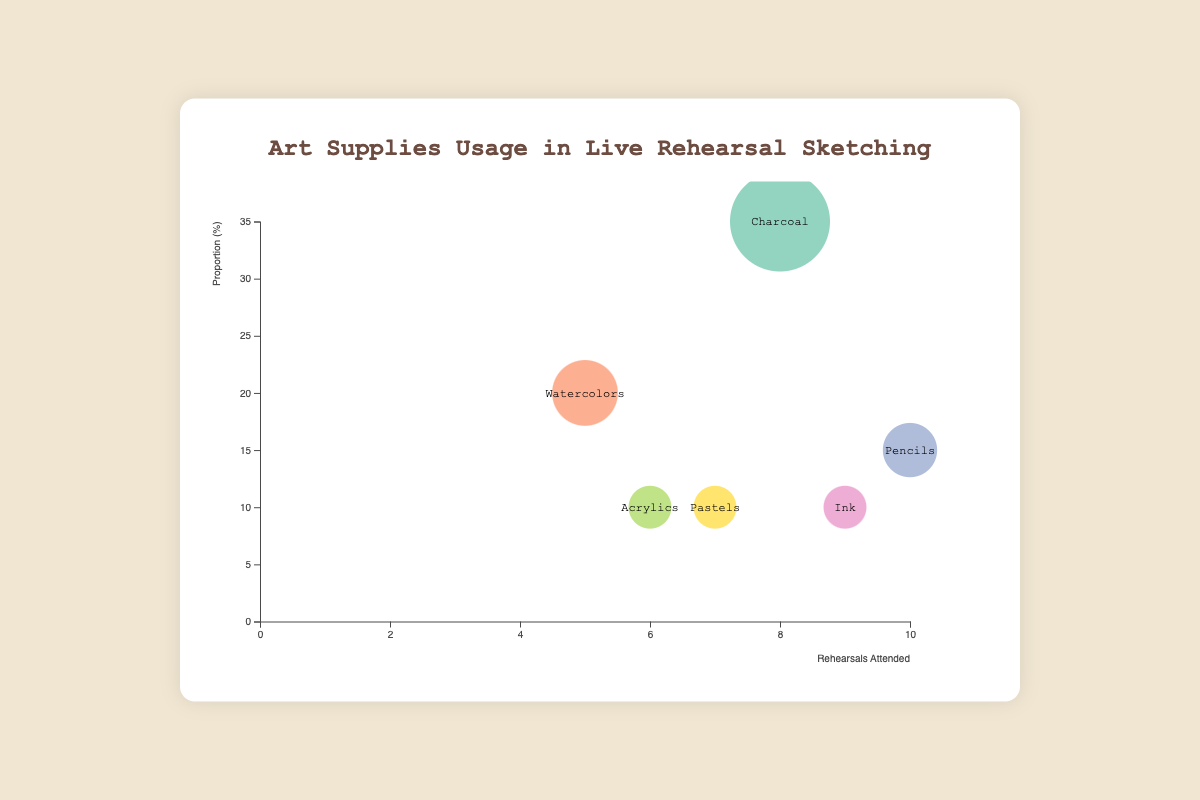What is the title of the figure? The title is usually displayed at the top of the chart.
Answer: Art Supplies Usage in Live Rehearsal Sketching How many different types of art supplies are represented in the figure? Counting the unique types of art supplies listed in the data points reveals the number of different types.
Answer: 6 Which artist uses Charcoal and what is their proportion of usage? By locating the bubble labeled "Charcoal" and checking the tooltip, you find the related artist and their usage proportion.
Answer: Winslow Homer, 35% Between Pastels and Ink, which type of art supply had more rehearsals attended? Compare the "Rehearsals Attended" values for "Pastels" and "Ink" from the bubbles or tooltips.
Answer: Ink What is the proportion percentage of Watercolors used by Georgia O'Keeffe? Recognize the bubble or check the tooltip for Watercolors to find the proportion used by Georgia O'Keeffe.
Answer: 20% Which art supply is least used, and which artist prefers it? Identify the smallest bubble or the lowest "Proportion" value from the chart, then refer to the artist associated with it.
Answer: Ink, Hokusai What is the average proportion of usage across all art supplies? Sum all the proportions and divide by the number of art supplies. (35+20+15+10+10+10) / 6 = 100 / 6
Answer: 16.67% Which two art supplies have the same proportion of usage, and what is that proportion? By reviewing the bubbles, note the art supplies with equal proportions and their corresponding values.
Answer: Ink, Acrylics, and Pastels, 10% What is the total number of rehearsals attended by the artists using Watercolors and Acrylics combined? Sum the "Rehearsals Attended" values for Watercolors and Acrylics. (5 + 6)
Answer: 11 Among the artists listed, who attended the most rehearsals and what art supply do they use? Identify the highest "Rehearsals Attended" value and refer to the associated artist and art supply.
Answer: Albrecht Dürer, Pencils 